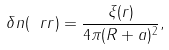Convert formula to latex. <formula><loc_0><loc_0><loc_500><loc_500>\delta n ( \ r r ) = \frac { \xi ( r ) } { 4 \pi ( R + a ) ^ { 2 } } ,</formula> 